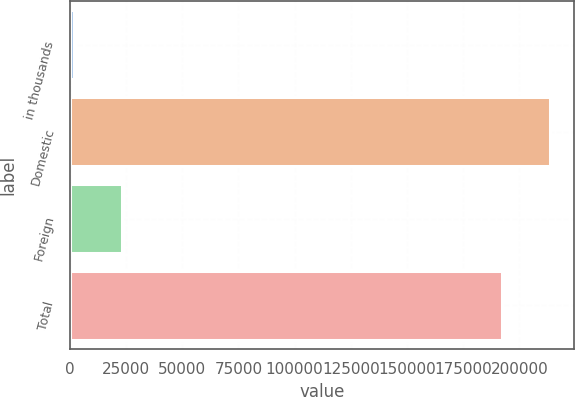Convert chart. <chart><loc_0><loc_0><loc_500><loc_500><bar_chart><fcel>in thousands<fcel>Domestic<fcel>Foreign<fcel>Total<nl><fcel>2010<fcel>213598<fcel>23168.8<fcel>192206<nl></chart> 